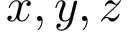<formula> <loc_0><loc_0><loc_500><loc_500>x , y , z</formula> 